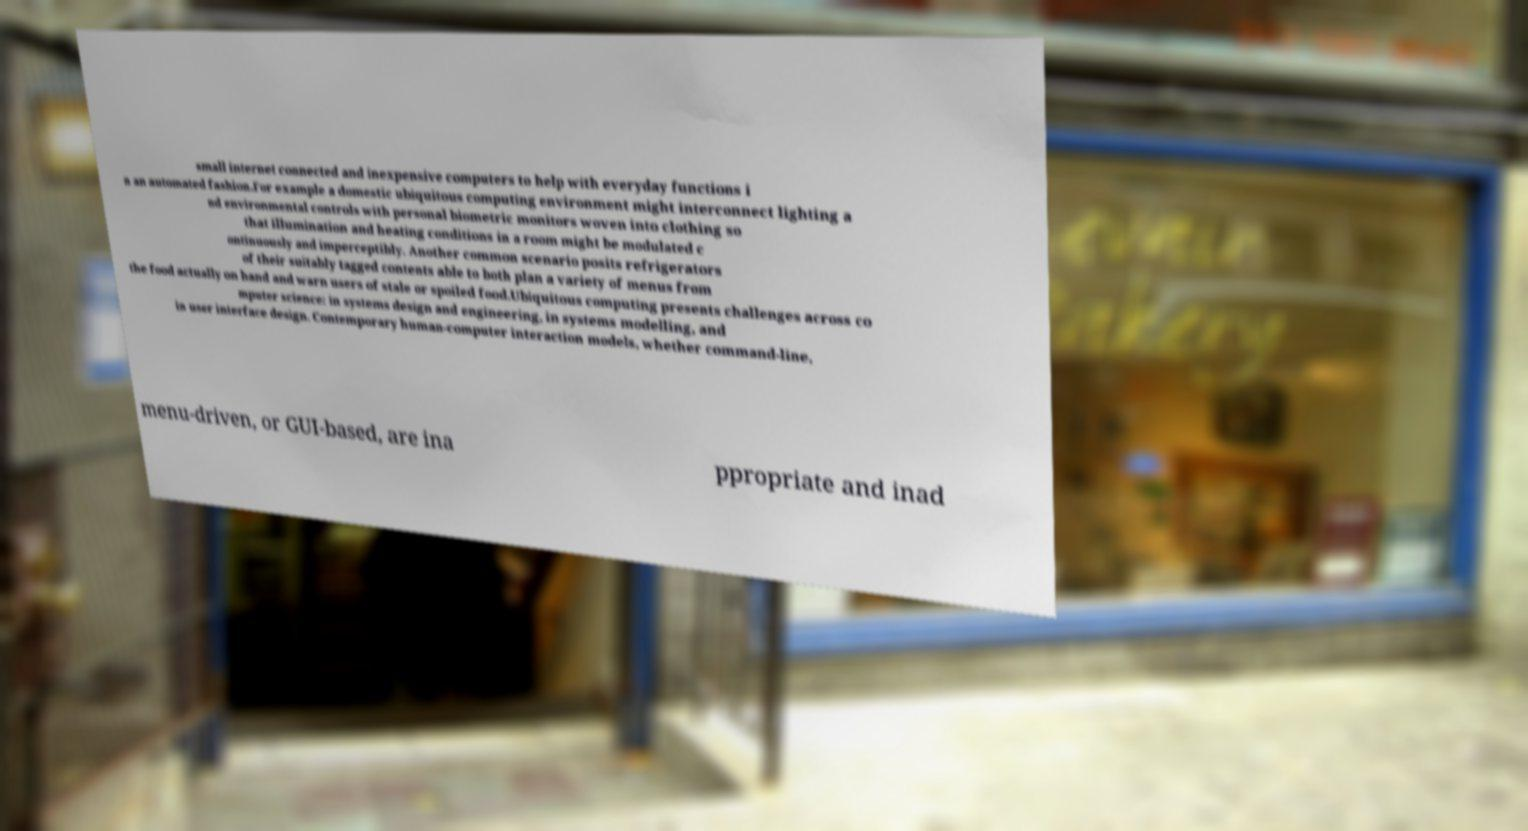I need the written content from this picture converted into text. Can you do that? small internet connected and inexpensive computers to help with everyday functions i n an automated fashion.For example a domestic ubiquitous computing environment might interconnect lighting a nd environmental controls with personal biometric monitors woven into clothing so that illumination and heating conditions in a room might be modulated c ontinuously and imperceptibly. Another common scenario posits refrigerators of their suitably tagged contents able to both plan a variety of menus from the food actually on hand and warn users of stale or spoiled food.Ubiquitous computing presents challenges across co mputer science: in systems design and engineering, in systems modelling, and in user interface design. Contemporary human-computer interaction models, whether command-line, menu-driven, or GUI-based, are ina ppropriate and inad 